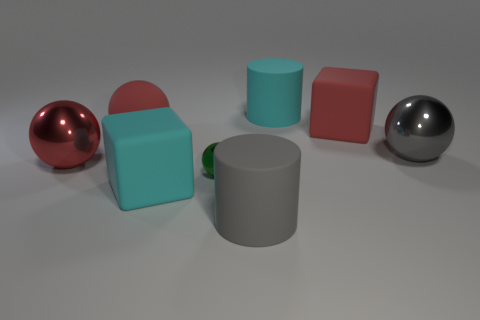If this were a part of a larger set, what other objects do you think could be included? If this image were part of a larger collection, we might expect to see additional geometric forms in various sizes and colors, possibly demonstrating a full range of shapes like cones, pyramids, or prisms. It's possible that the set would continue to showcase a mixture of materials as well, perhaps introducing objects with glassy or translucent textures to contrast with the opaque ones present. 